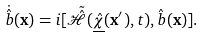Convert formula to latex. <formula><loc_0><loc_0><loc_500><loc_500>\dot { \hat { b } } ( { \mathbf x } ) = i [ \tilde { \hat { \mathcal { H } } } ( \underline { \hat { \chi } } ( { \mathbf x } ^ { \prime } ) , t ) , { \hat { b } } ( { \mathbf x } ) ] .</formula> 